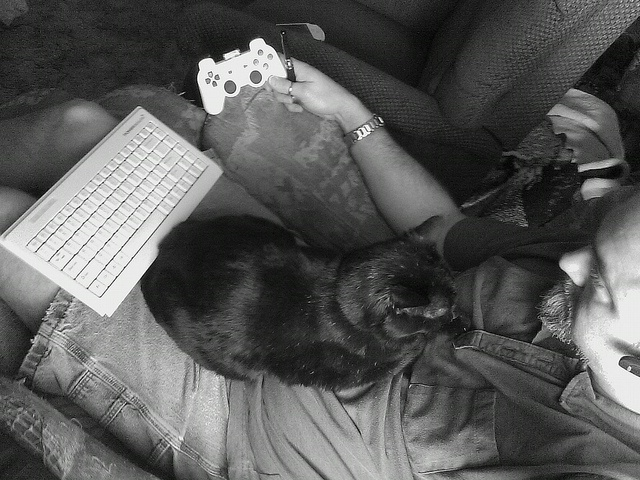Describe the objects in this image and their specific colors. I can see people in gray, darkgray, black, and lightgray tones, chair in gray and black tones, cat in gray and black tones, couch in gray and black tones, and keyboard in gray, lightgray, darkgray, and black tones in this image. 